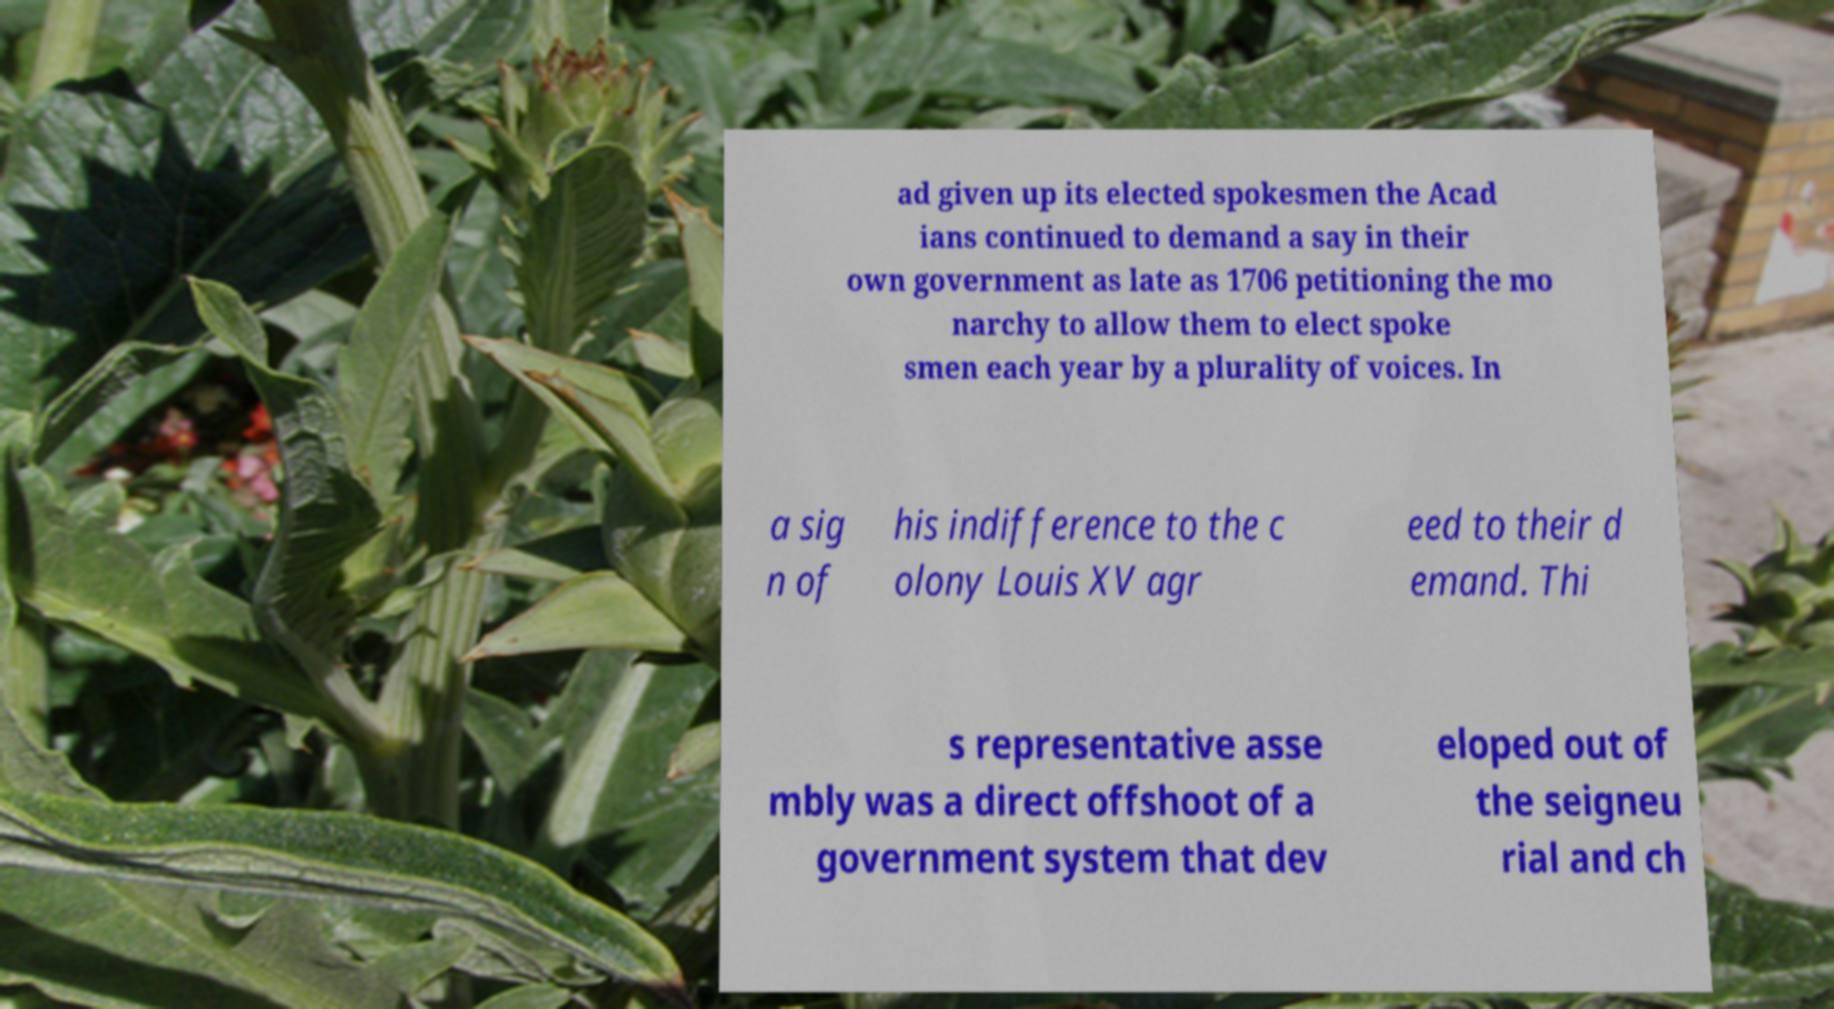There's text embedded in this image that I need extracted. Can you transcribe it verbatim? ad given up its elected spokesmen the Acad ians continued to demand a say in their own government as late as 1706 petitioning the mo narchy to allow them to elect spoke smen each year by a plurality of voices. In a sig n of his indifference to the c olony Louis XV agr eed to their d emand. Thi s representative asse mbly was a direct offshoot of a government system that dev eloped out of the seigneu rial and ch 